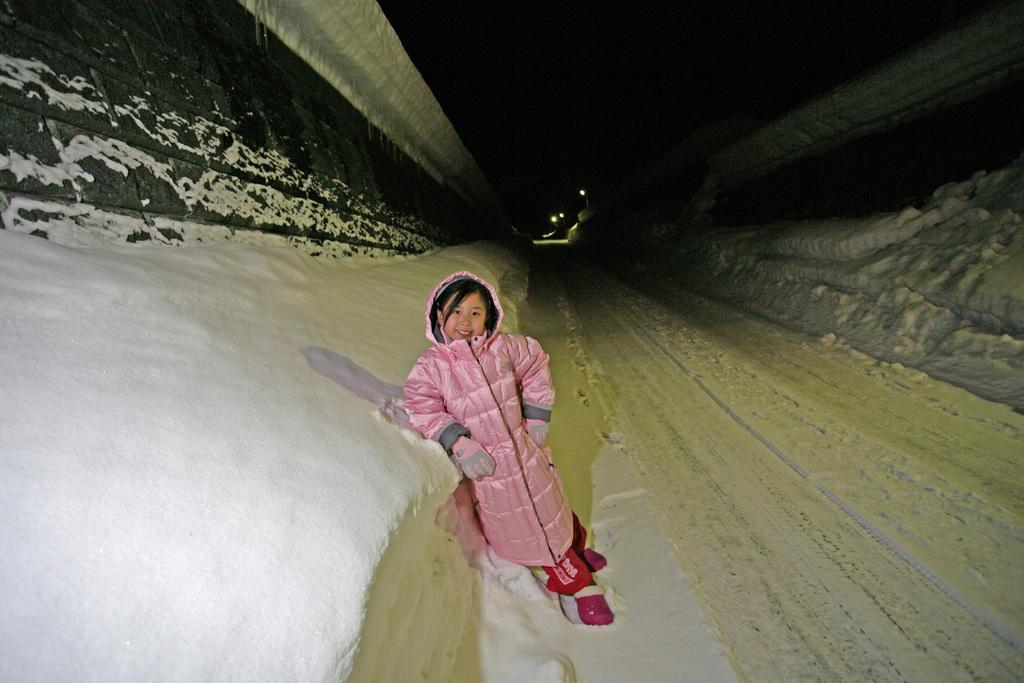In one or two sentences, can you explain what this image depicts? In this image we can see a child standing on the ground which is covered with snow. We can also see a wall with stones, a roof and some lights. 